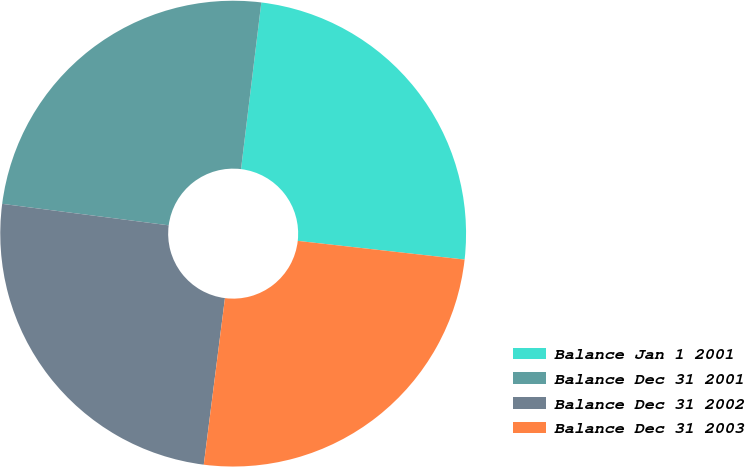<chart> <loc_0><loc_0><loc_500><loc_500><pie_chart><fcel>Balance Jan 1 2001<fcel>Balance Dec 31 2001<fcel>Balance Dec 31 2002<fcel>Balance Dec 31 2003<nl><fcel>24.85%<fcel>24.89%<fcel>25.03%<fcel>25.24%<nl></chart> 